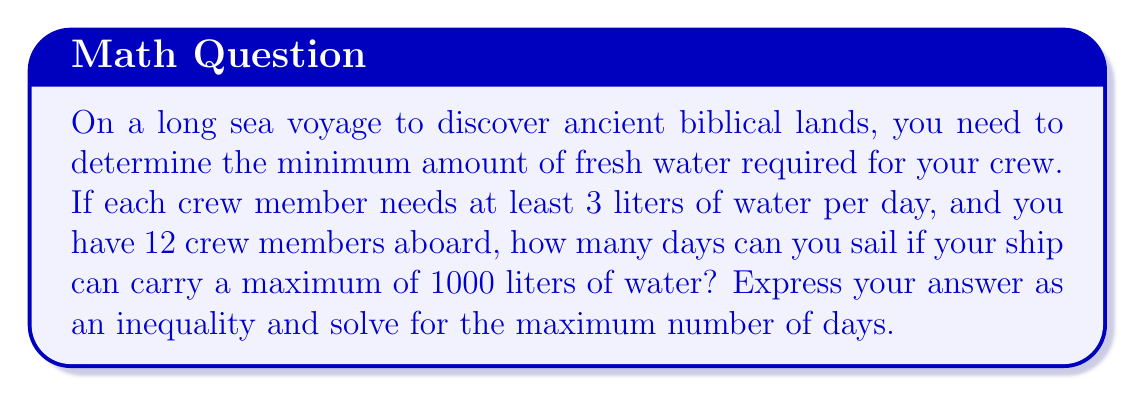Show me your answer to this math problem. Let's approach this step-by-step:

1) Let $x$ be the number of days the ship can sail.

2) Daily water consumption:
   - Each crew member needs 3 liters per day
   - There are 12 crew members
   - Total daily consumption: $3 \cdot 12 = 36$ liters

3) Set up the inequality:
   $36x \leq 1000$
   This inequality states that the total water consumed over $x$ days must be less than or equal to the maximum capacity.

4) Solve the inequality:
   $$36x \leq 1000$$
   $$x \leq \frac{1000}{36}$$
   $$x \leq 27.777...$$

5) Since we're looking for the maximum number of whole days, we need to round down to the nearest integer.
Answer: $x \leq 27$ days 